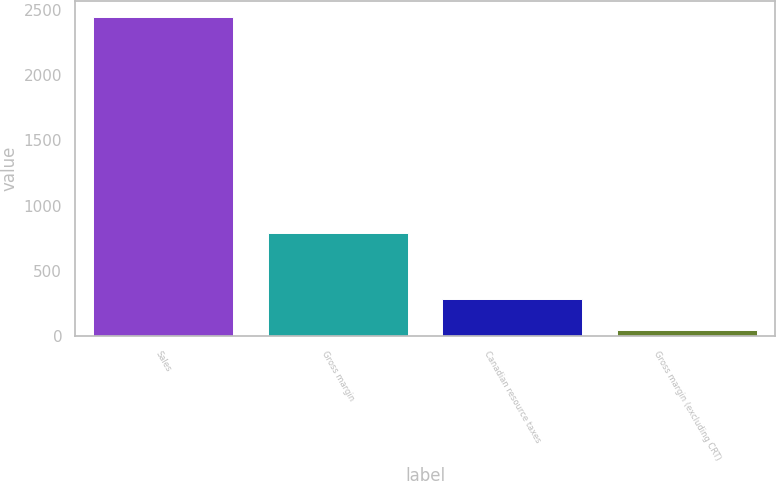Convert chart. <chart><loc_0><loc_0><loc_500><loc_500><bar_chart><fcel>Sales<fcel>Gross margin<fcel>Canadian resource taxes<fcel>Gross margin (excluding CRT)<nl><fcel>2447<fcel>788.3<fcel>282.77<fcel>42.3<nl></chart> 